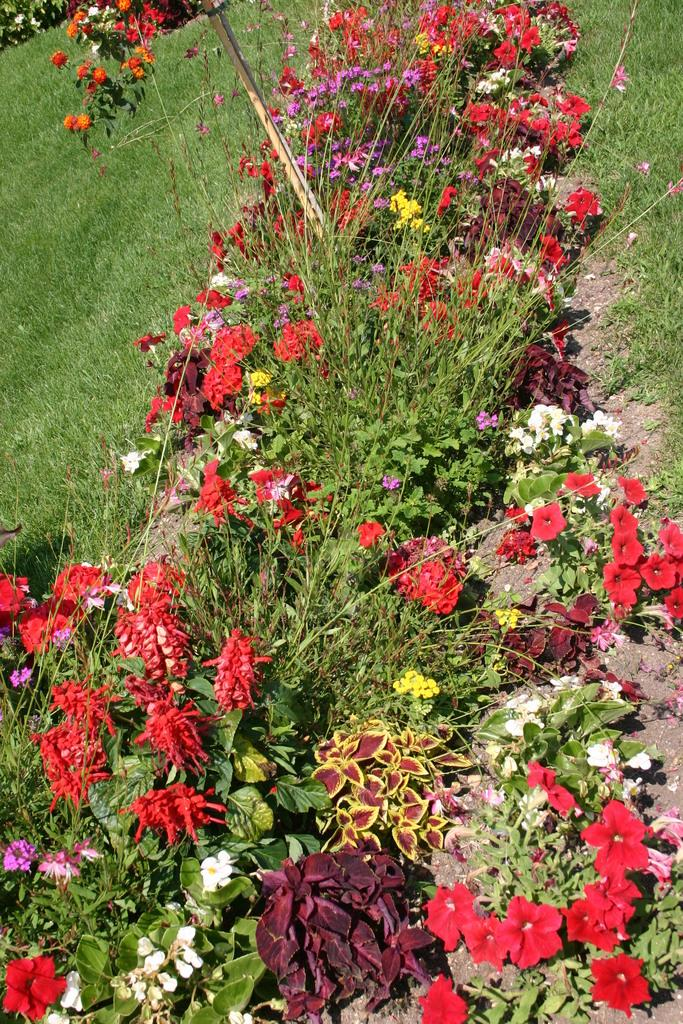What is located in the middle of the image? There are flower plants in the middle of the image. What type of vegetation can be seen on either side of the flower plants? There is grassland on either side of the flower plants. How many planes can be seen flying over the flower plants in the image? There are no planes visible in the image; it only features flower plants and grassland. What type of hair can be seen on the chickens in the image? There are no chickens present in the image, so it is not possible to determine what type of hair they might have. 